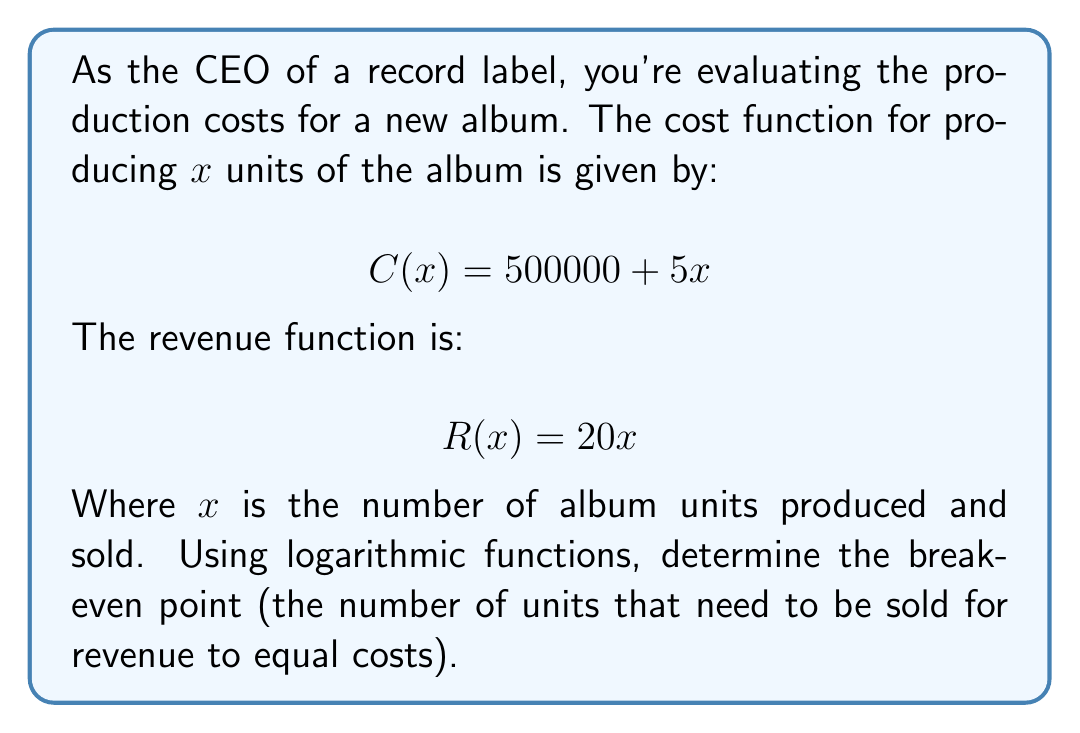Show me your answer to this math problem. To find the break-even point, we need to solve the equation where revenue equals costs:

$R(x) = C(x)$

Substituting the given functions:

$20x = 500000 + 5x$

Subtracting 5x from both sides:

$15x = 500000$

Dividing both sides by 15:

$x = \frac{500000}{15}$

To solve this using logarithms, we can take the logarithm of both sides:

$\log(x) = \log(\frac{500000}{15})$

Using the logarithm property $\log(a/b) = \log(a) - \log(b)$, we get:

$\log(x) = \log(500000) - \log(15)$

Now, we can solve for x by applying the exponential function to both sides:

$x = 10^{\log(500000) - \log(15)}$

Using a calculator or computer:

$x \approx 33333.33$

Since we can't sell a fraction of an album, we round up to the nearest whole number.
Answer: The break-even point is 33,334 units. 